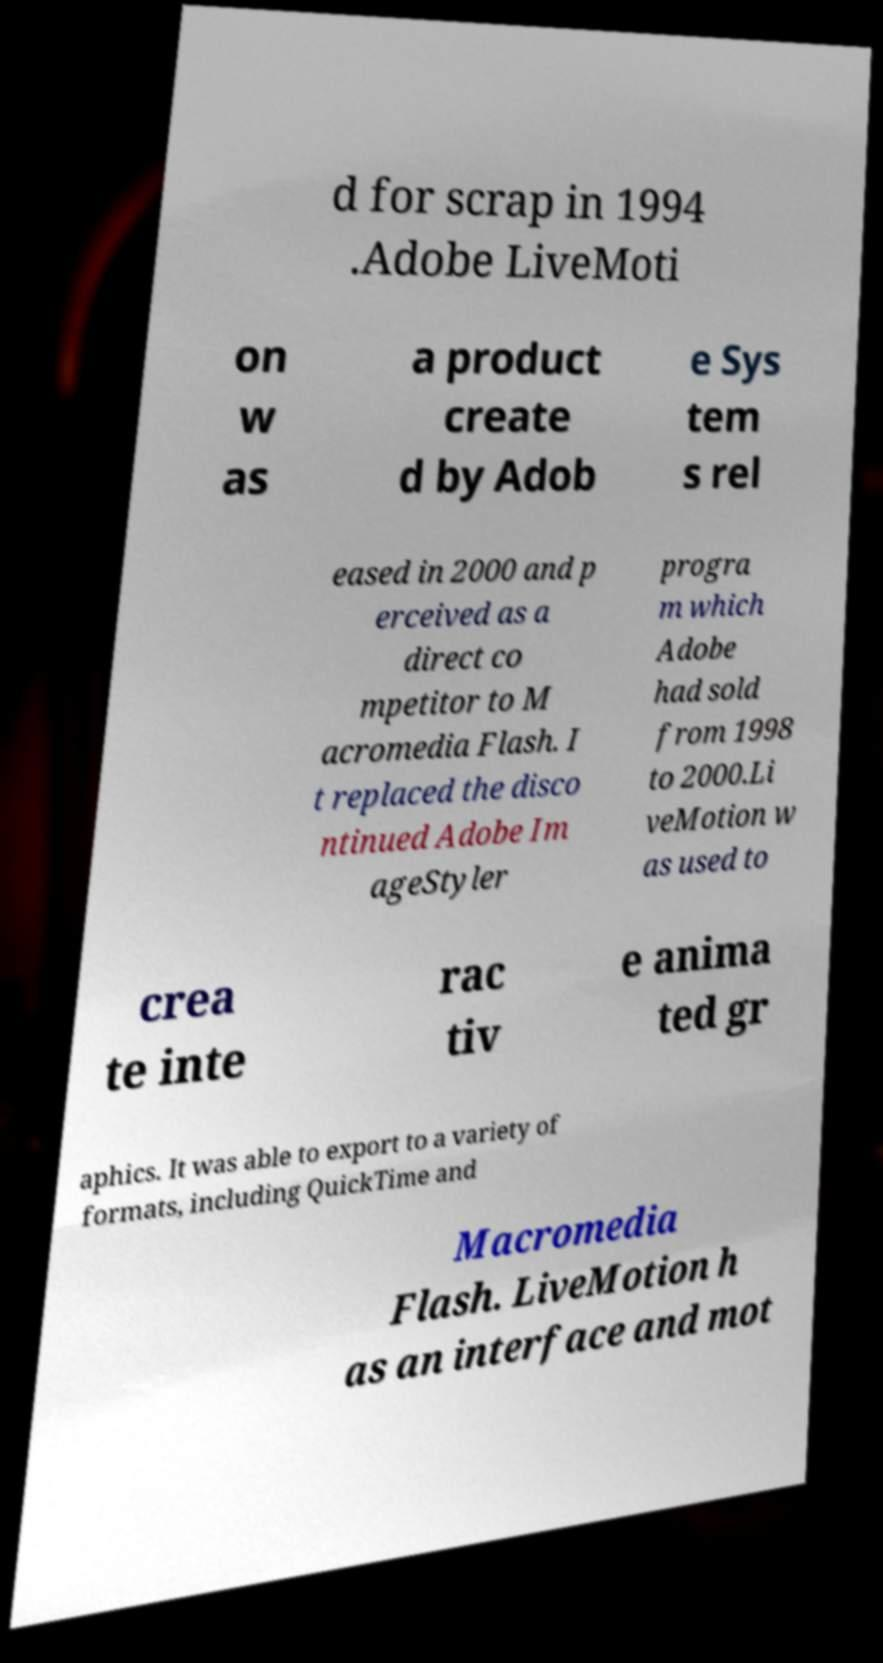Please read and relay the text visible in this image. What does it say? d for scrap in 1994 .Adobe LiveMoti on w as a product create d by Adob e Sys tem s rel eased in 2000 and p erceived as a direct co mpetitor to M acromedia Flash. I t replaced the disco ntinued Adobe Im ageStyler progra m which Adobe had sold from 1998 to 2000.Li veMotion w as used to crea te inte rac tiv e anima ted gr aphics. It was able to export to a variety of formats, including QuickTime and Macromedia Flash. LiveMotion h as an interface and mot 